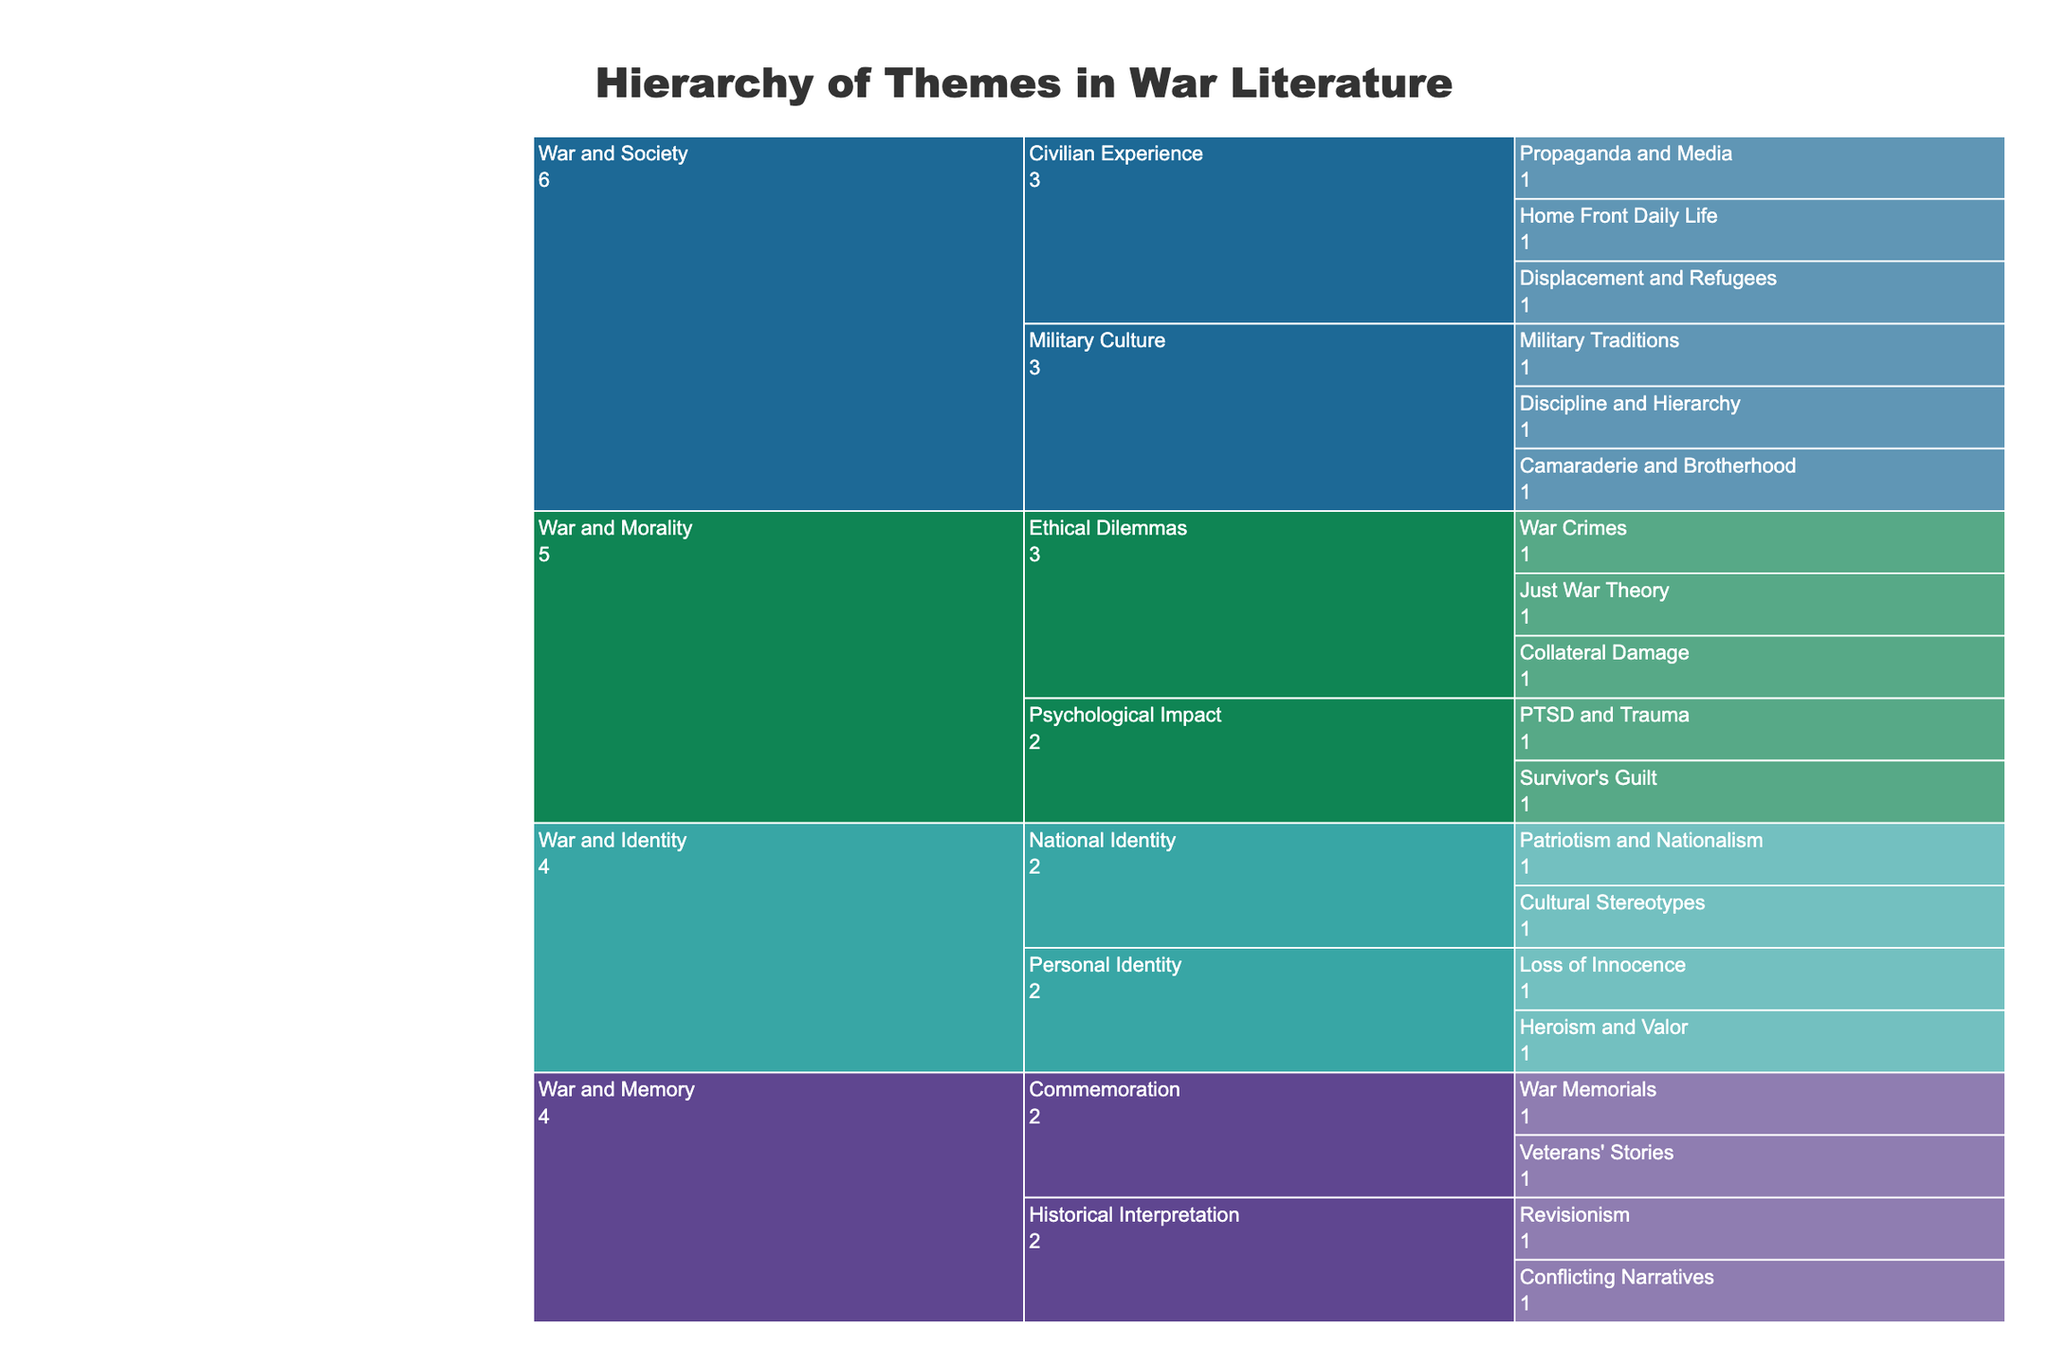what is the title of the icicle chart? The title is usually located at the top of the chart. It provides a brief and comprehensive description of what the chart represents. In this case, the title reads "Hierarchy of Themes in War Literature."
Answer: Hierarchy of Themes in War Literature How many primary themes are represented in the chart? To find the primary themes, one should look at the top-level categories in the icicle chart. They are typically the broadest categories from which the subthemes branch out. In this chart, these themes are "War and Society," "War and Morality," "War and Identity," and "War and Memory."
Answer: 4 Which primary theme contains the subtheme 'Ethical Dilemmas'? To answer this question, locate the subtheme "Ethical Dilemmas" within the chart and trace it back to its parent, the primary theme. "Ethical Dilemmas" is found under the primary theme "War and Morality."
Answer: War and Morality Compare the number of subthemes under the primary themes "War and Society" and "War and Identity." Which has more subthemes? To determine this, count the subthemes under each primary theme. "War and Society" has "Civilian Experience" and "Military Culture," giving it 2 subthemes. "War and Identity" has "National Identity" and "Personal Identity," also giving it 2 subthemes. Therefore, both have an equal number of subthemes.
Answer: Equal Which subtheme under "War and Memory" has more specific topics: 'Commemoration' or 'Historical Interpretation'? To answer this, count the specific topics under each subtheme. "Commemoration" has "War Memorials" and "Veterans' Stories" (2 topics), while "Historical Interpretation" has "Revisionism" and "Conflicting Narratives" (also 2 topics). Therefore, both subthemes have an equal number of specific topics.
Answer: Equal How many specific topics are associated with the subtheme 'Civilian Experience'? To answer, count all the specific topics under the subtheme "Civilian Experience." These are "Home Front Daily Life," "Propaganda and Media," and "Displacement and Refugees," totaling 3 specific topics.
Answer: 3 Which primary theme contains a subtheme related to psychological effects? Look for subthemes that mention psychological aspects and trace them back to their primary themes. "Psychological Impact," which includes "PTSD and Trauma" and "Survivor's Guilt," is under the primary theme "War and Morality."
Answer: War and Morality What is the specific topic related to national pride under "War and Identity"? To find this, locate the subtheme "National Identity" under "War and Identity" and identify the specific topics. Here, "Patriotism and Nationalism" relates to national pride.
Answer: Patriotism and Nationalism Which specific topics are associated with the subtheme 'Commemoration' under 'War and Memory'? Find the subtheme "Commemoration" under the primary theme "War and Memory" and list its specific topics. These are "War Memorials" and "Veterans' Stories."
Answer: War Memorials, Veterans' Stories 